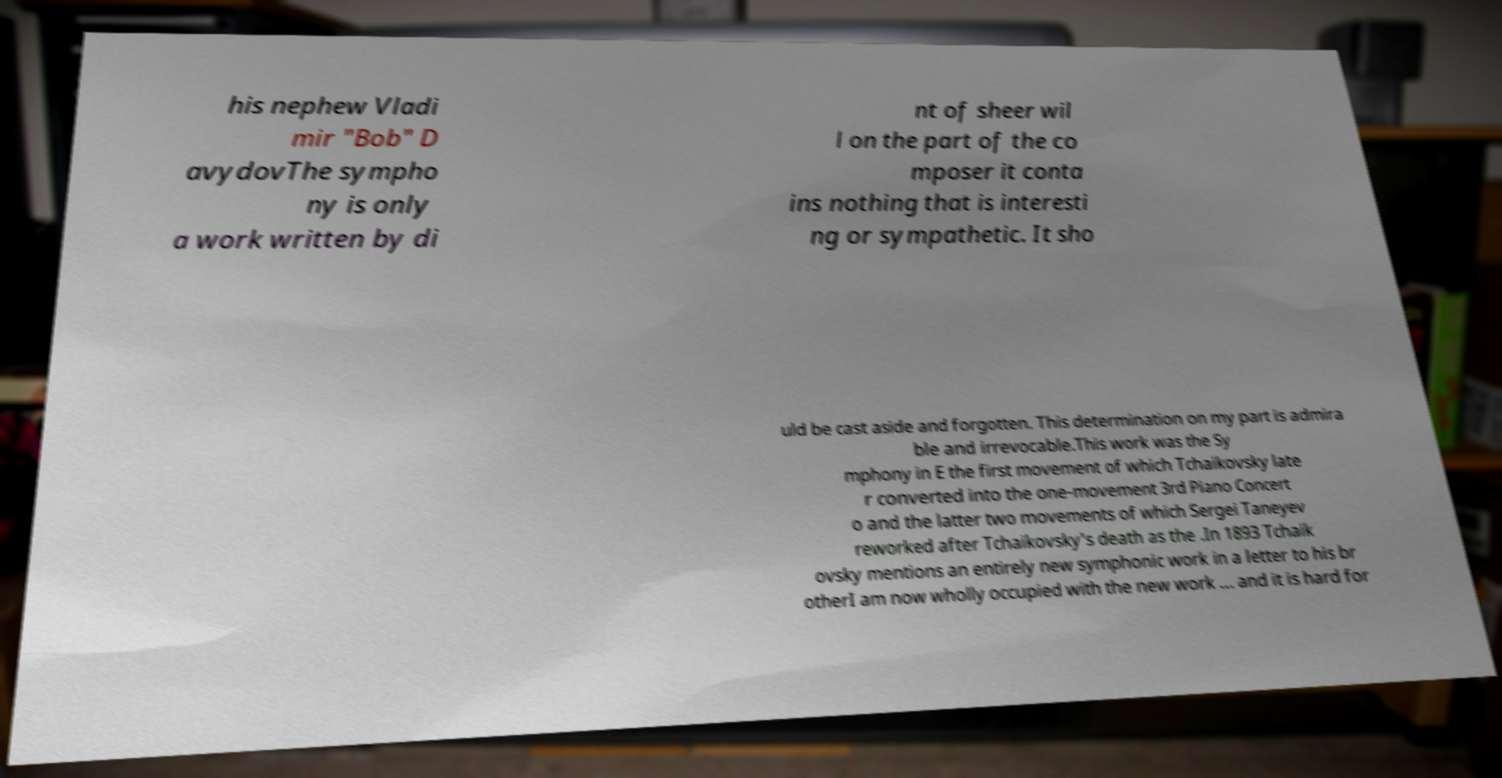What messages or text are displayed in this image? I need them in a readable, typed format. his nephew Vladi mir "Bob" D avydovThe sympho ny is only a work written by di nt of sheer wil l on the part of the co mposer it conta ins nothing that is interesti ng or sympathetic. It sho uld be cast aside and forgotten. This determination on my part is admira ble and irrevocable.This work was the Sy mphony in E the first movement of which Tchaikovsky late r converted into the one-movement 3rd Piano Concert o and the latter two movements of which Sergei Taneyev reworked after Tchaikovsky's death as the .In 1893 Tchaik ovsky mentions an entirely new symphonic work in a letter to his br otherI am now wholly occupied with the new work ... and it is hard for 